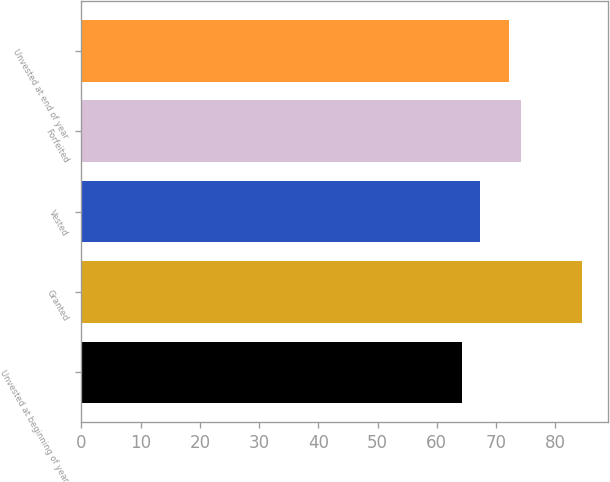<chart> <loc_0><loc_0><loc_500><loc_500><bar_chart><fcel>Unvested at beginning of year<fcel>Granted<fcel>Vested<fcel>Forfeited<fcel>Unvested at end of year<nl><fcel>64.27<fcel>84.61<fcel>67.36<fcel>74.28<fcel>72.25<nl></chart> 